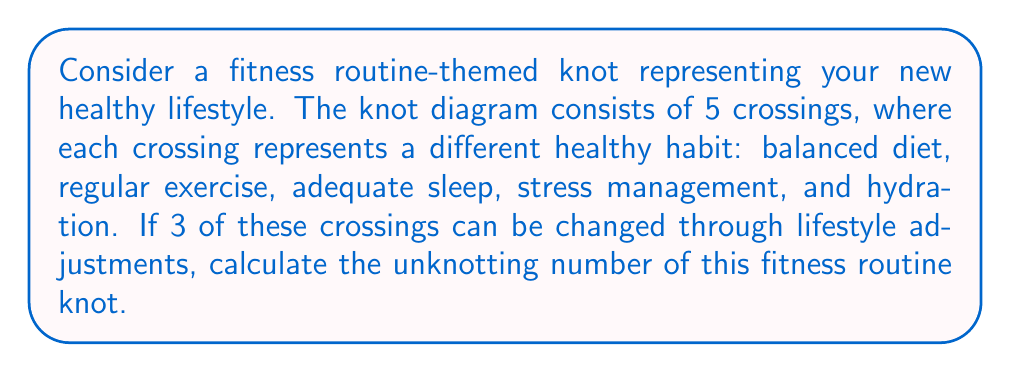Teach me how to tackle this problem. Let's approach this step-by-step:

1) First, recall that the unknotting number of a knot is the minimum number of crossing changes required to transform the knot into an unknot (trivial knot).

2) In this fitness routine-themed knot, we have 5 crossings in total, representing:
   - Balanced diet
   - Regular exercise
   - Adequate sleep
   - Stress management
   - Hydration

3) We're told that 3 of these crossings can be changed through lifestyle adjustments. In knot theory terms, this means we can change 3 of the 5 crossings.

4) The unknotting number is always less than or equal to the number of crossings that can be changed. In this case:

   $$ u(K) \leq 3 $$

   where $u(K)$ is the unknotting number of the knot $K$.

5) However, to determine if we actually need all 3 changes, we'd need more information about the specific configuration of the knot. Without this information, we assume the worst case scenario where all allowed changes are necessary.

6) Therefore, in this case, the unknotting number is equal to the number of crossings that can be changed:

   $$ u(K) = 3 $$

This means that by making changes in 3 out of the 5 areas of your fitness routine (e.g., improving your diet, starting regular exercise, and getting better sleep), you can "unknot" your lifestyle and achieve a healthier balance.
Answer: 3 